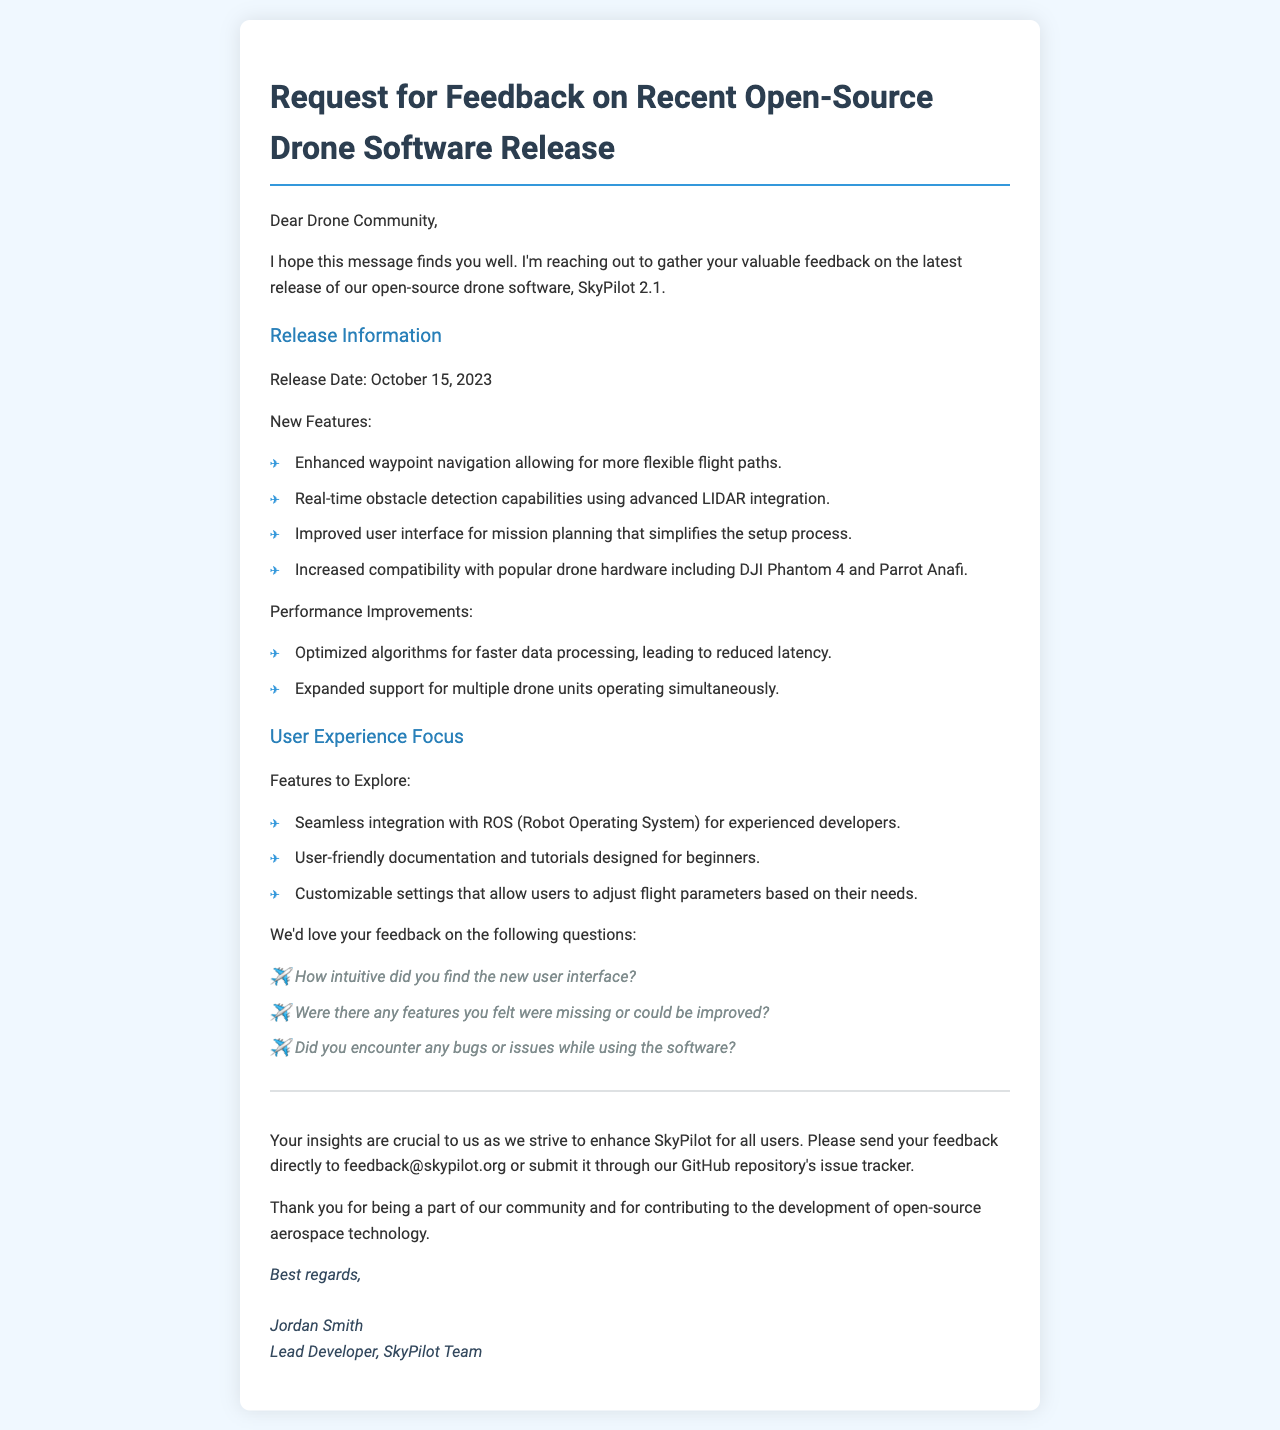What is the release date of SkyPilot 2.1? The release date is explicitly mentioned in the document.
Answer: October 15, 2023 What is one of the new features introduced in this release? The document lists new features under 'New Features'.
Answer: Enhanced waypoint navigation How many performance improvements are listed in the document? The document mentions a specific number of performance improvements.
Answer: Two What is the email address provided for feedback? The document includes a specific contact email for feedback.
Answer: feedback@skypilot.org Which drone hardware is mentioned for increased compatibility? The document specifies particular drone hardware compatible with the software.
Answer: DJI Phantom 4 and Parrot Anafi How did the author describe the new user interface? The document uses a specific term to describe the user interface.
Answer: Improved What type of software does the document mention for integration? The document specifically mentions the type of software for seamless integration.
Answer: ROS (Robot Operating System) What feedback aspect does the author ask about bugs or issues? The document raises a specific query related to any problems encountered.
Answer: Yes 